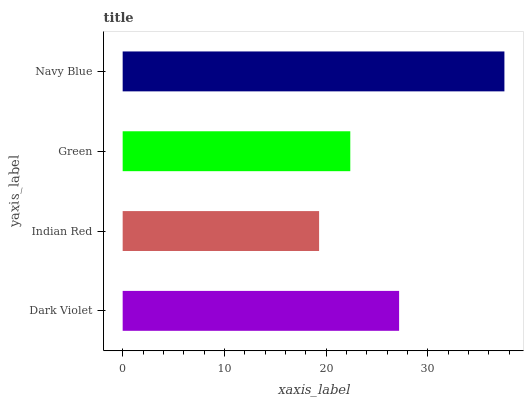Is Indian Red the minimum?
Answer yes or no. Yes. Is Navy Blue the maximum?
Answer yes or no. Yes. Is Green the minimum?
Answer yes or no. No. Is Green the maximum?
Answer yes or no. No. Is Green greater than Indian Red?
Answer yes or no. Yes. Is Indian Red less than Green?
Answer yes or no. Yes. Is Indian Red greater than Green?
Answer yes or no. No. Is Green less than Indian Red?
Answer yes or no. No. Is Dark Violet the high median?
Answer yes or no. Yes. Is Green the low median?
Answer yes or no. Yes. Is Navy Blue the high median?
Answer yes or no. No. Is Dark Violet the low median?
Answer yes or no. No. 